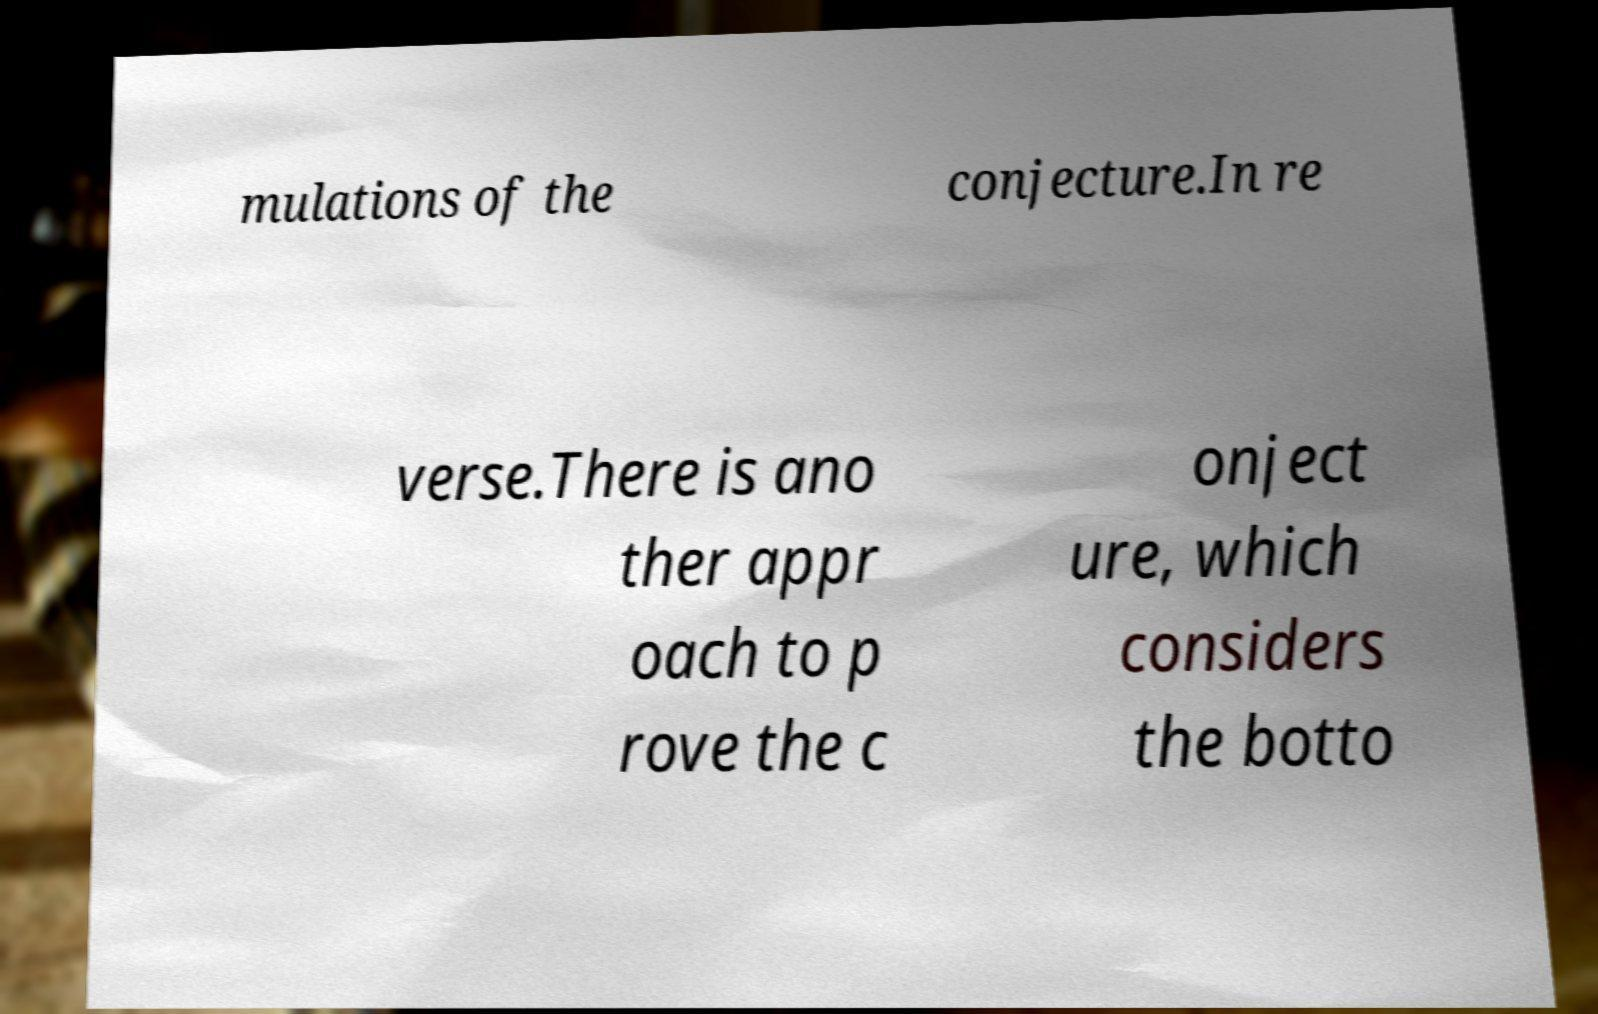What messages or text are displayed in this image? I need them in a readable, typed format. mulations of the conjecture.In re verse.There is ano ther appr oach to p rove the c onject ure, which considers the botto 